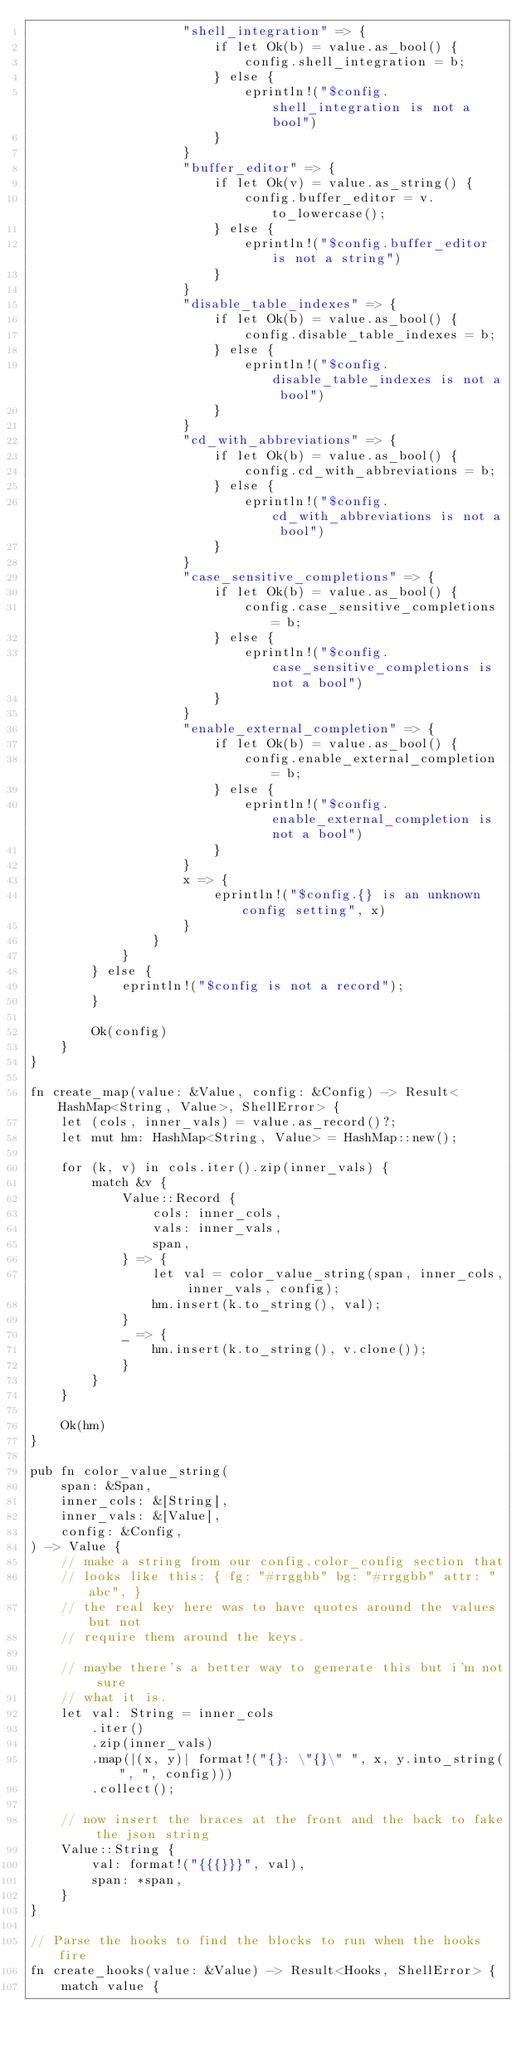Convert code to text. <code><loc_0><loc_0><loc_500><loc_500><_Rust_>                    "shell_integration" => {
                        if let Ok(b) = value.as_bool() {
                            config.shell_integration = b;
                        } else {
                            eprintln!("$config.shell_integration is not a bool")
                        }
                    }
                    "buffer_editor" => {
                        if let Ok(v) = value.as_string() {
                            config.buffer_editor = v.to_lowercase();
                        } else {
                            eprintln!("$config.buffer_editor is not a string")
                        }
                    }
                    "disable_table_indexes" => {
                        if let Ok(b) = value.as_bool() {
                            config.disable_table_indexes = b;
                        } else {
                            eprintln!("$config.disable_table_indexes is not a bool")
                        }
                    }
                    "cd_with_abbreviations" => {
                        if let Ok(b) = value.as_bool() {
                            config.cd_with_abbreviations = b;
                        } else {
                            eprintln!("$config.cd_with_abbreviations is not a bool")
                        }
                    }
                    "case_sensitive_completions" => {
                        if let Ok(b) = value.as_bool() {
                            config.case_sensitive_completions = b;
                        } else {
                            eprintln!("$config.case_sensitive_completions is not a bool")
                        }
                    }
                    "enable_external_completion" => {
                        if let Ok(b) = value.as_bool() {
                            config.enable_external_completion = b;
                        } else {
                            eprintln!("$config.enable_external_completion is not a bool")
                        }
                    }
                    x => {
                        eprintln!("$config.{} is an unknown config setting", x)
                    }
                }
            }
        } else {
            eprintln!("$config is not a record");
        }

        Ok(config)
    }
}

fn create_map(value: &Value, config: &Config) -> Result<HashMap<String, Value>, ShellError> {
    let (cols, inner_vals) = value.as_record()?;
    let mut hm: HashMap<String, Value> = HashMap::new();

    for (k, v) in cols.iter().zip(inner_vals) {
        match &v {
            Value::Record {
                cols: inner_cols,
                vals: inner_vals,
                span,
            } => {
                let val = color_value_string(span, inner_cols, inner_vals, config);
                hm.insert(k.to_string(), val);
            }
            _ => {
                hm.insert(k.to_string(), v.clone());
            }
        }
    }

    Ok(hm)
}

pub fn color_value_string(
    span: &Span,
    inner_cols: &[String],
    inner_vals: &[Value],
    config: &Config,
) -> Value {
    // make a string from our config.color_config section that
    // looks like this: { fg: "#rrggbb" bg: "#rrggbb" attr: "abc", }
    // the real key here was to have quotes around the values but not
    // require them around the keys.

    // maybe there's a better way to generate this but i'm not sure
    // what it is.
    let val: String = inner_cols
        .iter()
        .zip(inner_vals)
        .map(|(x, y)| format!("{}: \"{}\" ", x, y.into_string(", ", config)))
        .collect();

    // now insert the braces at the front and the back to fake the json string
    Value::String {
        val: format!("{{{}}}", val),
        span: *span,
    }
}

// Parse the hooks to find the blocks to run when the hooks fire
fn create_hooks(value: &Value) -> Result<Hooks, ShellError> {
    match value {</code> 